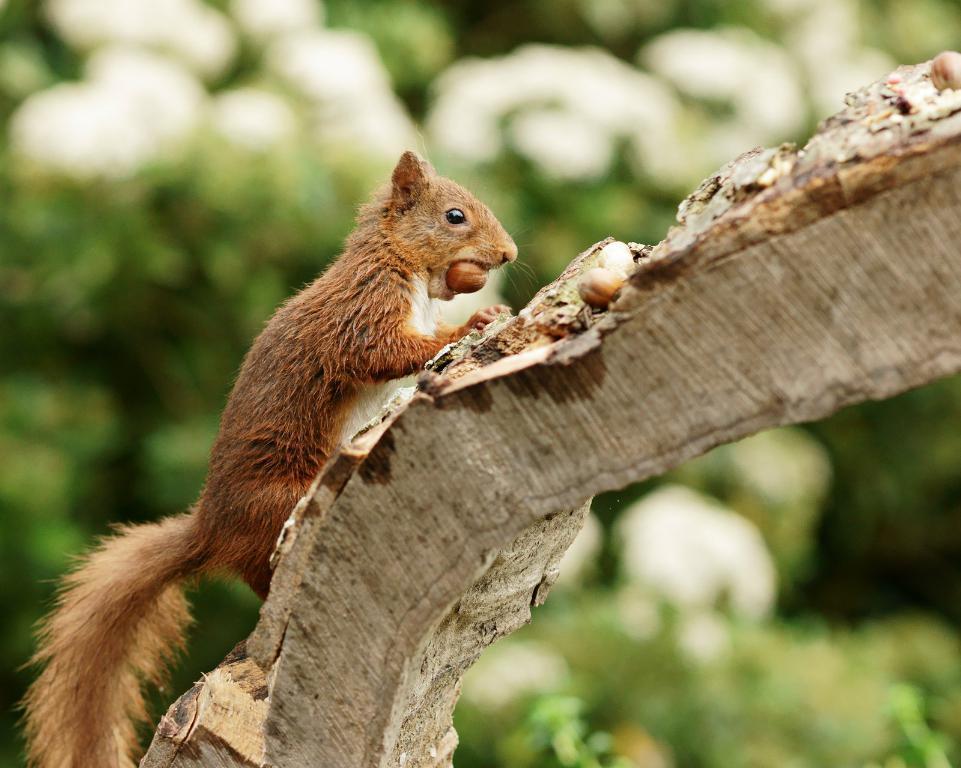Could you give a brief overview of what you see in this image? In this picture I can see a squirrel on the wood and I can see a nut in its mouth and I can see trees. 